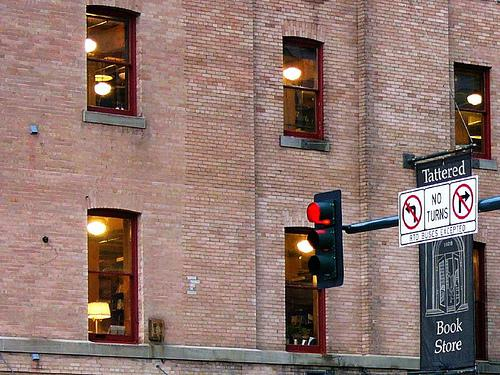Question: how many buildings are in the photo?
Choices:
A. 3.
B. 5.
C. 1.
D. 6.
Answer with the letter. Answer: C Question: what does the sign indicate is not allowed?
Choices:
A. No speeding.
B. No Turns.
C. No texting.
D. No crossing.
Answer with the letter. Answer: B Question: what does the black sign say?
Choices:
A. Welcome.
B. The name of the store.
C. Tattered Book Store.
D. Name of street.
Answer with the letter. Answer: C 